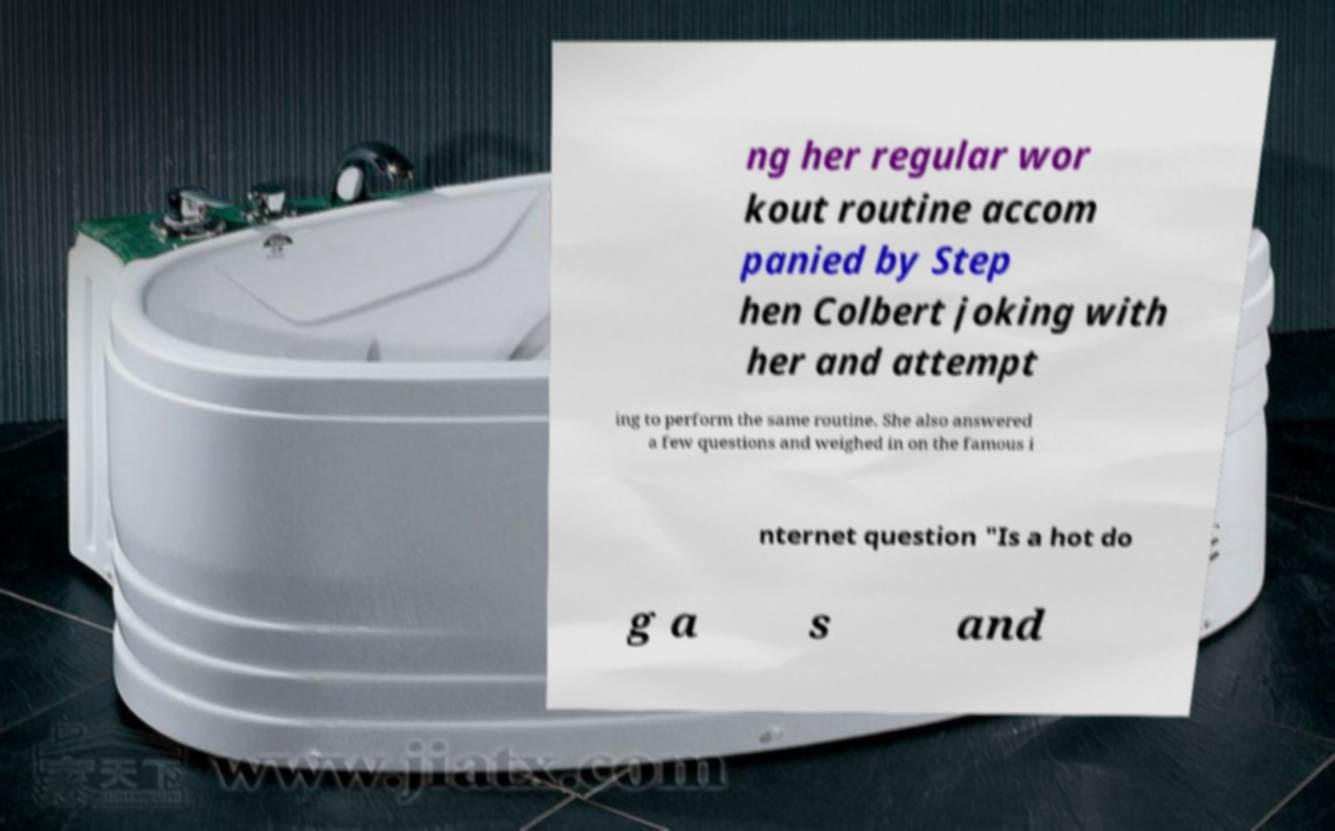Can you accurately transcribe the text from the provided image for me? ng her regular wor kout routine accom panied by Step hen Colbert joking with her and attempt ing to perform the same routine. She also answered a few questions and weighed in on the famous i nternet question "Is a hot do g a s and 